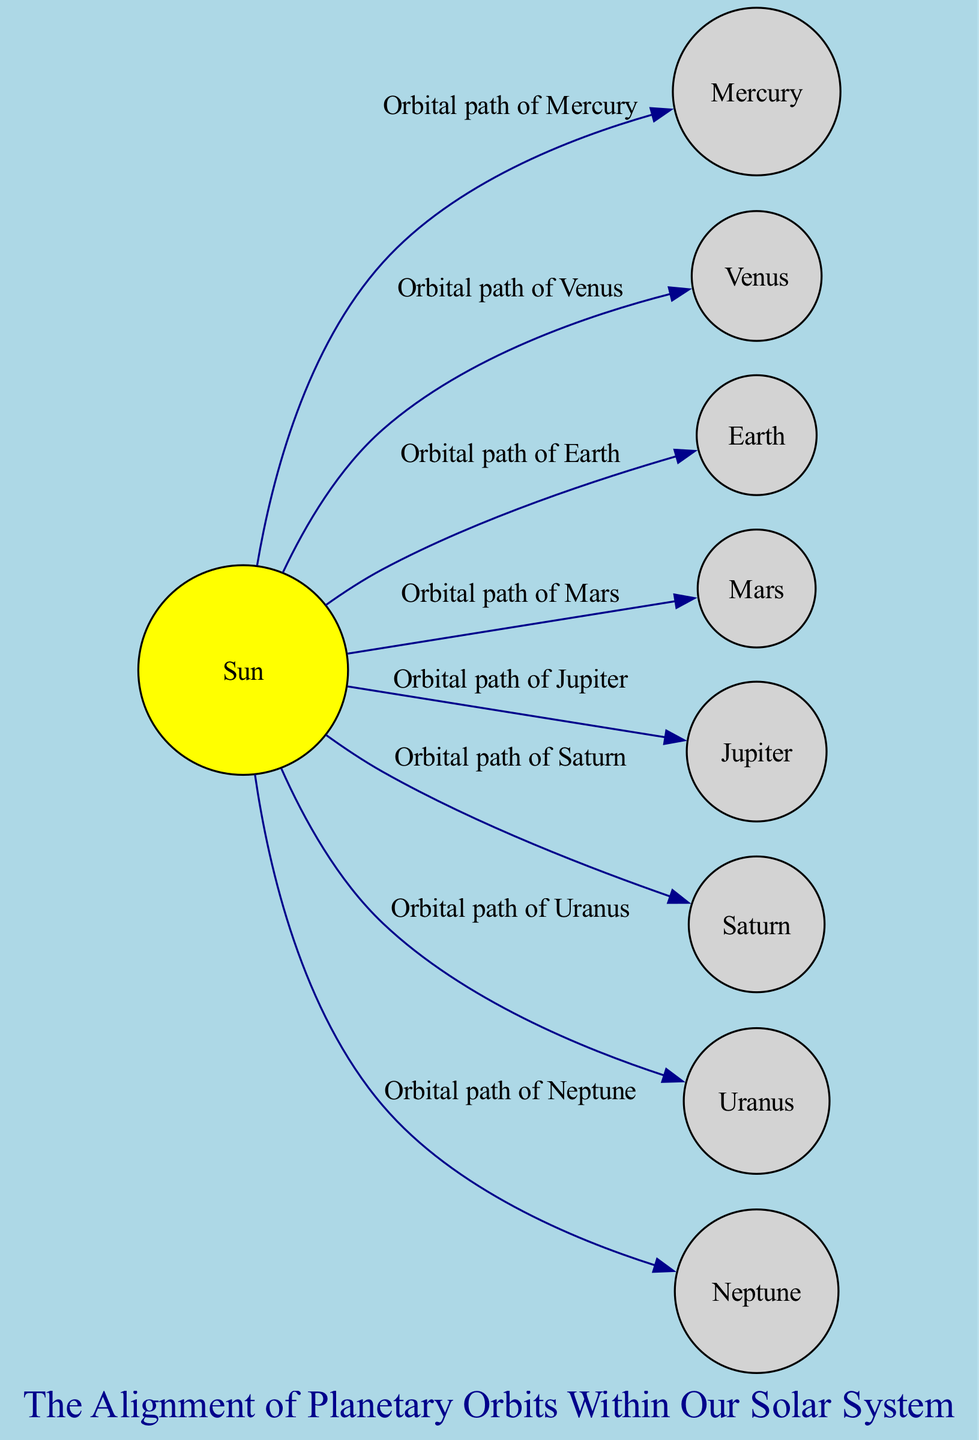What is the central star of the solar system? The diagram clearly identifies the node labeled "Sun" as the central star, which is represented at the center of the diagram.
Answer: Sun How many planets are there in this diagram? By counting the nodes labeled from Mercury to Neptune, we find there are a total of eight planets represented in the diagram.
Answer: Eight Which planet has the orbital path labeled "Orbital path of Mars"? The edge from the Sun to the node labeled "Mars" is clearly stated to represent the orbital path of Mars.
Answer: Mars What is the seventh planet from the Sun? The diagram labels Uranus as the seventh planet, indicating its position relative to the Sun and other planets.
Answer: Uranus Which planet is known for its ring system? The label "Saturn" attached to its node indicates that Saturn is recognized for having a prominent ring system around it.
Answer: Saturn What relationship connects Jupiter and the Sun? The edge labeled "Orbital path of Jupiter" connects the Sun and Jupiter, indicating the relationship of Jupiter's orbit around the Sun.
Answer: Orbital path of Jupiter Which planet is closest to the Sun? The diagram shows Mercury being the closest planet to the Sun, evident from its position in the sequence of planets.
Answer: Mercury Which planet has a tilted axis? The diagram describes Uranus as having a tilted axis, indicating a unique rotational characteristic in the solar system.
Answer: Uranus What is the orbital path of Neptune? The diagram specifies the edge connecting the Sun to Neptune as "Orbital path of Neptune," indicating its relationship with the Sun.
Answer: Orbital path of Neptune 